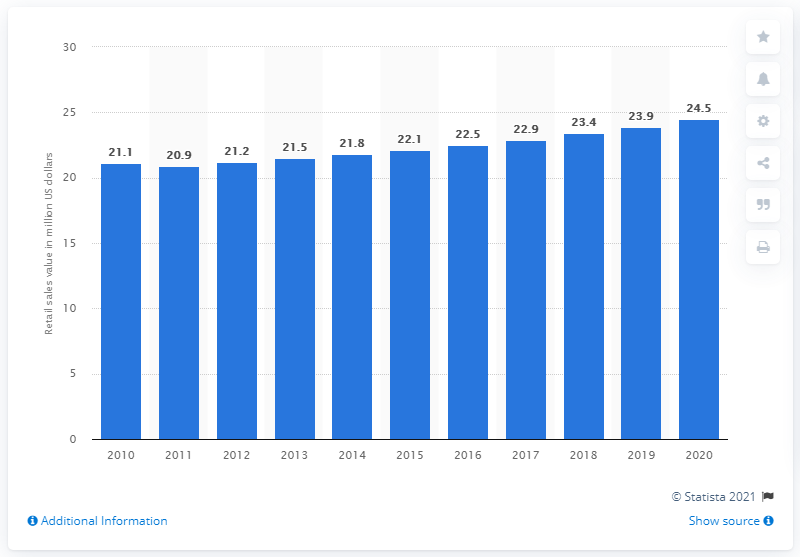Draw attention to some important aspects in this diagram. The retail sales value of organic biscuits and snack bars in 2010 was approximately 21.2 million dollars. The retail sales value of organic biscuits and snack bars in Germany was expected to reach a certain amount in 2015, estimated to be higher than the value in 2010. The retail sales value of organic biscuits and snack bars is forecasted to be approximately 24.5 billion dollars in 2020. 